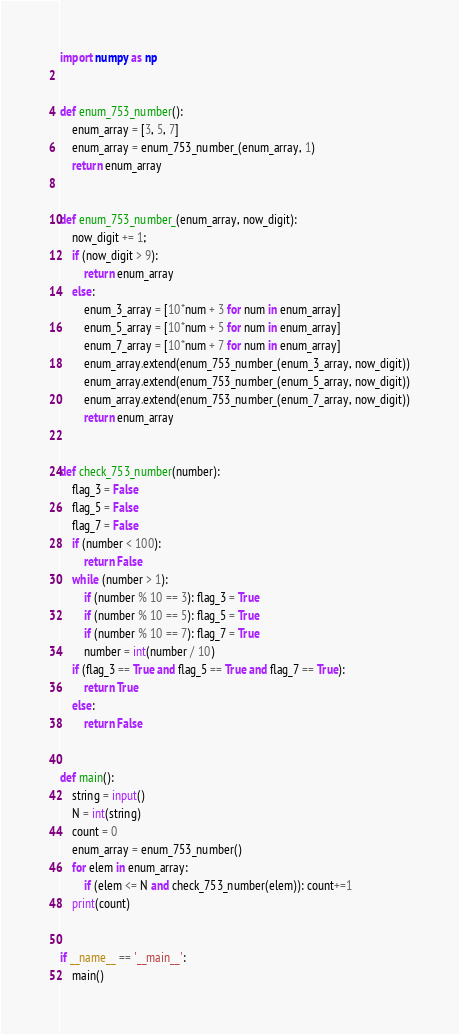Convert code to text. <code><loc_0><loc_0><loc_500><loc_500><_Python_>import numpy as np


def enum_753_number():
    enum_array = [3, 5, 7]
    enum_array = enum_753_number_(enum_array, 1)
    return enum_array


def enum_753_number_(enum_array, now_digit):
    now_digit += 1;
    if (now_digit > 9):
        return enum_array
    else:
        enum_3_array = [10*num + 3 for num in enum_array]
        enum_5_array = [10*num + 5 for num in enum_array]
        enum_7_array = [10*num + 7 for num in enum_array]
        enum_array.extend(enum_753_number_(enum_3_array, now_digit))
        enum_array.extend(enum_753_number_(enum_5_array, now_digit))
        enum_array.extend(enum_753_number_(enum_7_array, now_digit))
        return enum_array


def check_753_number(number):
    flag_3 = False
    flag_5 = False
    flag_7 = False
    if (number < 100):
        return False
    while (number > 1):
        if (number % 10 == 3): flag_3 = True
        if (number % 10 == 5): flag_5 = True
        if (number % 10 == 7): flag_7 = True
        number = int(number / 10)
    if (flag_3 == True and flag_5 == True and flag_7 == True):
        return True
    else:
        return False


def main():
    string = input()
    N = int(string)
    count = 0
    enum_array = enum_753_number()
    for elem in enum_array:
        if (elem <= N and check_753_number(elem)): count+=1
    print(count)


if __name__ == '__main__':
    main()
</code> 